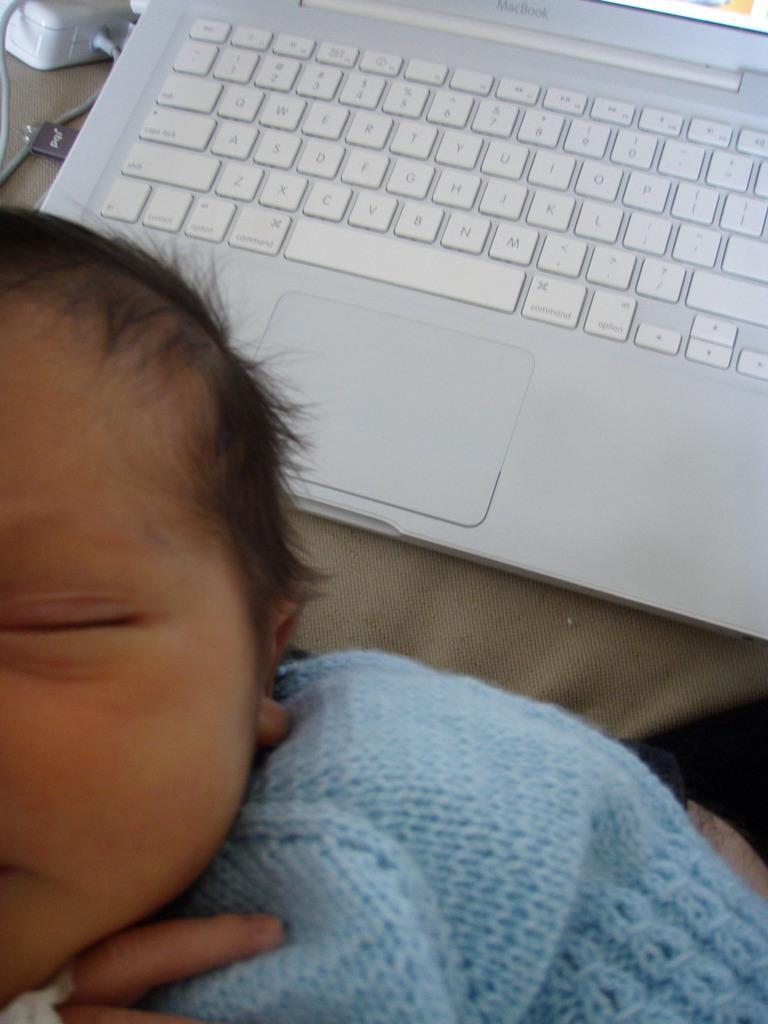Describe this image in one or two sentences. At the bottom left corner a baby is there. In the center of the image laptop is there. At the top left corner switch board, wires are there. In the middle of the image cloth is there. 